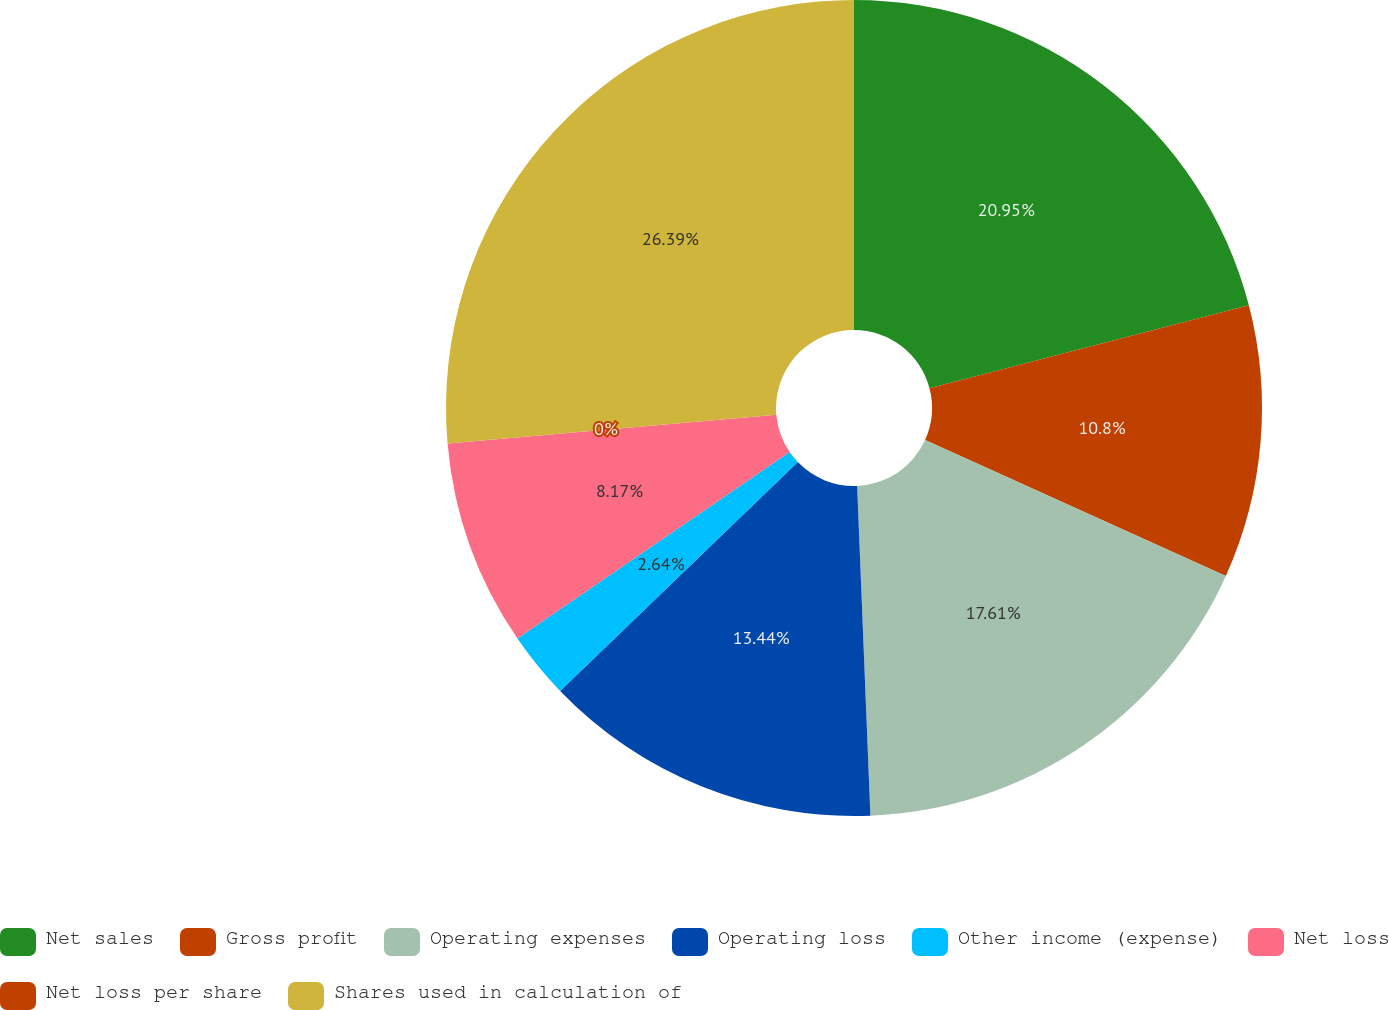<chart> <loc_0><loc_0><loc_500><loc_500><pie_chart><fcel>Net sales<fcel>Gross profit<fcel>Operating expenses<fcel>Operating loss<fcel>Other income (expense)<fcel>Net loss<fcel>Net loss per share<fcel>Shares used in calculation of<nl><fcel>20.95%<fcel>10.8%<fcel>17.61%<fcel>13.44%<fcel>2.64%<fcel>8.17%<fcel>0.0%<fcel>26.39%<nl></chart> 